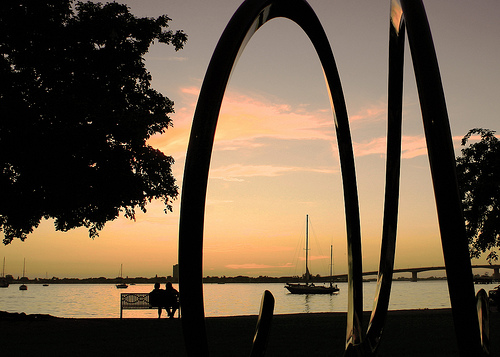<image>
Is there a sculpture next to the bench? Yes. The sculpture is positioned adjacent to the bench, located nearby in the same general area. 